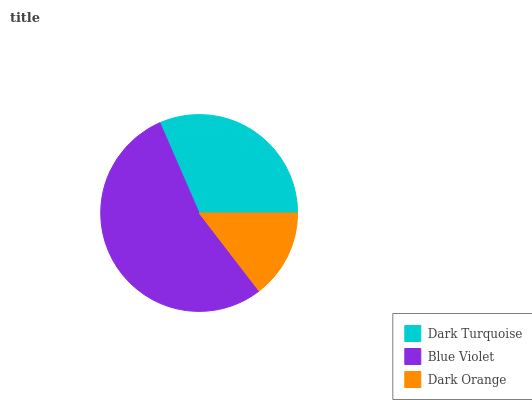Is Dark Orange the minimum?
Answer yes or no. Yes. Is Blue Violet the maximum?
Answer yes or no. Yes. Is Blue Violet the minimum?
Answer yes or no. No. Is Dark Orange the maximum?
Answer yes or no. No. Is Blue Violet greater than Dark Orange?
Answer yes or no. Yes. Is Dark Orange less than Blue Violet?
Answer yes or no. Yes. Is Dark Orange greater than Blue Violet?
Answer yes or no. No. Is Blue Violet less than Dark Orange?
Answer yes or no. No. Is Dark Turquoise the high median?
Answer yes or no. Yes. Is Dark Turquoise the low median?
Answer yes or no. Yes. Is Dark Orange the high median?
Answer yes or no. No. Is Dark Orange the low median?
Answer yes or no. No. 